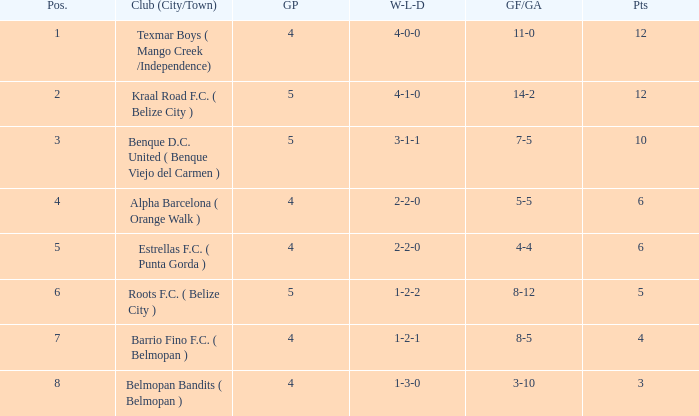What is the minimum points with goals for/against being 8-5 4.0. 